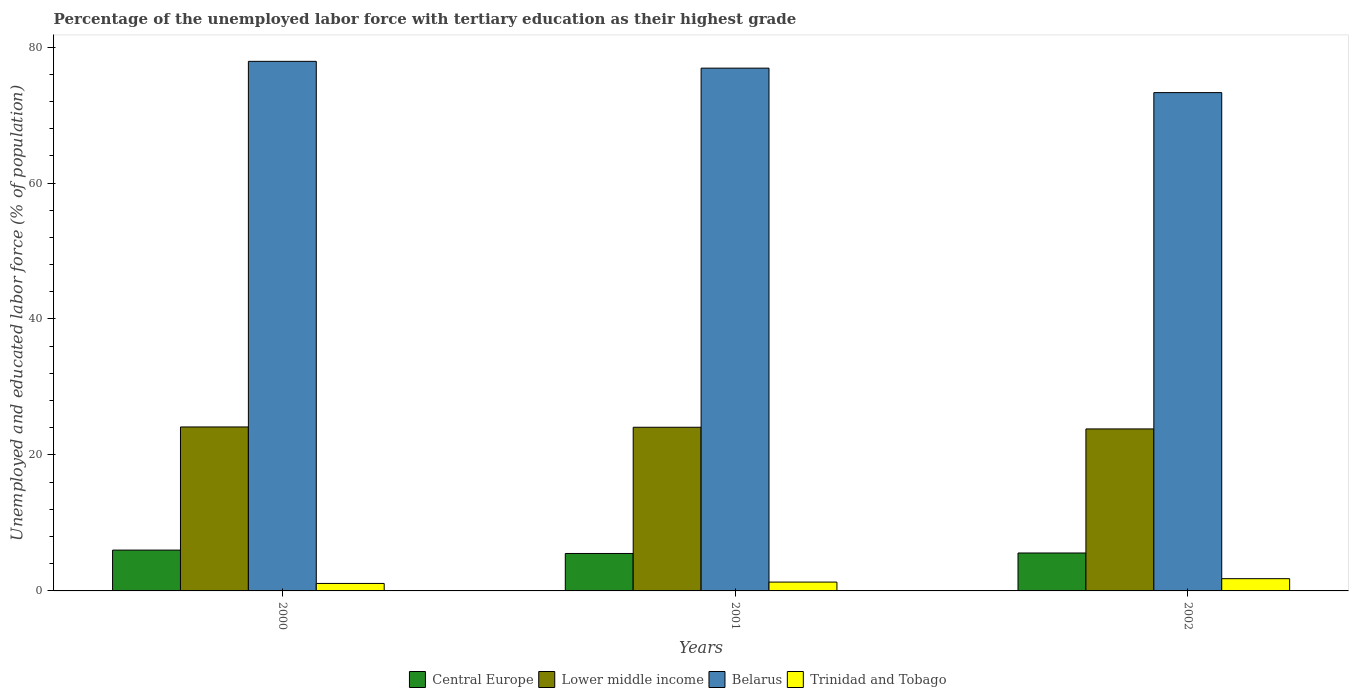How many bars are there on the 1st tick from the left?
Keep it short and to the point. 4. What is the label of the 2nd group of bars from the left?
Make the answer very short. 2001. In how many cases, is the number of bars for a given year not equal to the number of legend labels?
Offer a terse response. 0. What is the percentage of the unemployed labor force with tertiary education in Belarus in 2000?
Provide a succinct answer. 77.9. Across all years, what is the maximum percentage of the unemployed labor force with tertiary education in Lower middle income?
Provide a short and direct response. 24.12. Across all years, what is the minimum percentage of the unemployed labor force with tertiary education in Lower middle income?
Your answer should be compact. 23.83. In which year was the percentage of the unemployed labor force with tertiary education in Trinidad and Tobago minimum?
Keep it short and to the point. 2000. What is the total percentage of the unemployed labor force with tertiary education in Central Europe in the graph?
Your response must be concise. 17.09. What is the difference between the percentage of the unemployed labor force with tertiary education in Lower middle income in 2001 and that in 2002?
Make the answer very short. 0.25. What is the difference between the percentage of the unemployed labor force with tertiary education in Trinidad and Tobago in 2000 and the percentage of the unemployed labor force with tertiary education in Belarus in 2001?
Your answer should be compact. -75.8. What is the average percentage of the unemployed labor force with tertiary education in Central Europe per year?
Provide a short and direct response. 5.7. In the year 2001, what is the difference between the percentage of the unemployed labor force with tertiary education in Central Europe and percentage of the unemployed labor force with tertiary education in Trinidad and Tobago?
Keep it short and to the point. 4.21. What is the ratio of the percentage of the unemployed labor force with tertiary education in Trinidad and Tobago in 2000 to that in 2002?
Ensure brevity in your answer.  0.61. Is the difference between the percentage of the unemployed labor force with tertiary education in Central Europe in 2000 and 2002 greater than the difference between the percentage of the unemployed labor force with tertiary education in Trinidad and Tobago in 2000 and 2002?
Your response must be concise. Yes. What is the difference between the highest and the lowest percentage of the unemployed labor force with tertiary education in Central Europe?
Ensure brevity in your answer.  0.5. In how many years, is the percentage of the unemployed labor force with tertiary education in Central Europe greater than the average percentage of the unemployed labor force with tertiary education in Central Europe taken over all years?
Your response must be concise. 1. Is the sum of the percentage of the unemployed labor force with tertiary education in Central Europe in 2000 and 2002 greater than the maximum percentage of the unemployed labor force with tertiary education in Lower middle income across all years?
Offer a very short reply. No. Is it the case that in every year, the sum of the percentage of the unemployed labor force with tertiary education in Lower middle income and percentage of the unemployed labor force with tertiary education in Central Europe is greater than the sum of percentage of the unemployed labor force with tertiary education in Belarus and percentage of the unemployed labor force with tertiary education in Trinidad and Tobago?
Provide a short and direct response. Yes. What does the 1st bar from the left in 2001 represents?
Keep it short and to the point. Central Europe. What does the 3rd bar from the right in 2001 represents?
Make the answer very short. Lower middle income. Is it the case that in every year, the sum of the percentage of the unemployed labor force with tertiary education in Central Europe and percentage of the unemployed labor force with tertiary education in Lower middle income is greater than the percentage of the unemployed labor force with tertiary education in Trinidad and Tobago?
Offer a terse response. Yes. How many bars are there?
Make the answer very short. 12. What is the difference between two consecutive major ticks on the Y-axis?
Your response must be concise. 20. Are the values on the major ticks of Y-axis written in scientific E-notation?
Offer a very short reply. No. Does the graph contain any zero values?
Keep it short and to the point. No. Does the graph contain grids?
Offer a very short reply. No. How are the legend labels stacked?
Give a very brief answer. Horizontal. What is the title of the graph?
Provide a short and direct response. Percentage of the unemployed labor force with tertiary education as their highest grade. Does "Cameroon" appear as one of the legend labels in the graph?
Provide a short and direct response. No. What is the label or title of the Y-axis?
Your answer should be very brief. Unemployed and educated labor force (% of population). What is the Unemployed and educated labor force (% of population) of Central Europe in 2000?
Your answer should be compact. 6.01. What is the Unemployed and educated labor force (% of population) in Lower middle income in 2000?
Keep it short and to the point. 24.12. What is the Unemployed and educated labor force (% of population) of Belarus in 2000?
Make the answer very short. 77.9. What is the Unemployed and educated labor force (% of population) in Trinidad and Tobago in 2000?
Make the answer very short. 1.1. What is the Unemployed and educated labor force (% of population) in Central Europe in 2001?
Provide a succinct answer. 5.51. What is the Unemployed and educated labor force (% of population) of Lower middle income in 2001?
Your response must be concise. 24.08. What is the Unemployed and educated labor force (% of population) of Belarus in 2001?
Ensure brevity in your answer.  76.9. What is the Unemployed and educated labor force (% of population) of Trinidad and Tobago in 2001?
Your answer should be very brief. 1.3. What is the Unemployed and educated labor force (% of population) in Central Europe in 2002?
Offer a terse response. 5.58. What is the Unemployed and educated labor force (% of population) of Lower middle income in 2002?
Ensure brevity in your answer.  23.83. What is the Unemployed and educated labor force (% of population) in Belarus in 2002?
Offer a terse response. 73.3. What is the Unemployed and educated labor force (% of population) in Trinidad and Tobago in 2002?
Offer a very short reply. 1.8. Across all years, what is the maximum Unemployed and educated labor force (% of population) of Central Europe?
Your answer should be compact. 6.01. Across all years, what is the maximum Unemployed and educated labor force (% of population) of Lower middle income?
Your response must be concise. 24.12. Across all years, what is the maximum Unemployed and educated labor force (% of population) in Belarus?
Ensure brevity in your answer.  77.9. Across all years, what is the maximum Unemployed and educated labor force (% of population) in Trinidad and Tobago?
Offer a very short reply. 1.8. Across all years, what is the minimum Unemployed and educated labor force (% of population) in Central Europe?
Offer a very short reply. 5.51. Across all years, what is the minimum Unemployed and educated labor force (% of population) of Lower middle income?
Ensure brevity in your answer.  23.83. Across all years, what is the minimum Unemployed and educated labor force (% of population) in Belarus?
Your answer should be compact. 73.3. Across all years, what is the minimum Unemployed and educated labor force (% of population) of Trinidad and Tobago?
Provide a short and direct response. 1.1. What is the total Unemployed and educated labor force (% of population) in Central Europe in the graph?
Offer a terse response. 17.09. What is the total Unemployed and educated labor force (% of population) of Lower middle income in the graph?
Provide a short and direct response. 72.03. What is the total Unemployed and educated labor force (% of population) in Belarus in the graph?
Provide a short and direct response. 228.1. What is the total Unemployed and educated labor force (% of population) of Trinidad and Tobago in the graph?
Ensure brevity in your answer.  4.2. What is the difference between the Unemployed and educated labor force (% of population) in Central Europe in 2000 and that in 2001?
Keep it short and to the point. 0.5. What is the difference between the Unemployed and educated labor force (% of population) in Lower middle income in 2000 and that in 2001?
Your answer should be compact. 0.04. What is the difference between the Unemployed and educated labor force (% of population) in Trinidad and Tobago in 2000 and that in 2001?
Give a very brief answer. -0.2. What is the difference between the Unemployed and educated labor force (% of population) of Central Europe in 2000 and that in 2002?
Provide a short and direct response. 0.43. What is the difference between the Unemployed and educated labor force (% of population) of Lower middle income in 2000 and that in 2002?
Your response must be concise. 0.29. What is the difference between the Unemployed and educated labor force (% of population) in Belarus in 2000 and that in 2002?
Provide a short and direct response. 4.6. What is the difference between the Unemployed and educated labor force (% of population) of Trinidad and Tobago in 2000 and that in 2002?
Make the answer very short. -0.7. What is the difference between the Unemployed and educated labor force (% of population) in Central Europe in 2001 and that in 2002?
Provide a short and direct response. -0.07. What is the difference between the Unemployed and educated labor force (% of population) in Lower middle income in 2001 and that in 2002?
Ensure brevity in your answer.  0.25. What is the difference between the Unemployed and educated labor force (% of population) of Belarus in 2001 and that in 2002?
Ensure brevity in your answer.  3.6. What is the difference between the Unemployed and educated labor force (% of population) of Central Europe in 2000 and the Unemployed and educated labor force (% of population) of Lower middle income in 2001?
Your response must be concise. -18.07. What is the difference between the Unemployed and educated labor force (% of population) of Central Europe in 2000 and the Unemployed and educated labor force (% of population) of Belarus in 2001?
Keep it short and to the point. -70.89. What is the difference between the Unemployed and educated labor force (% of population) in Central Europe in 2000 and the Unemployed and educated labor force (% of population) in Trinidad and Tobago in 2001?
Provide a short and direct response. 4.71. What is the difference between the Unemployed and educated labor force (% of population) in Lower middle income in 2000 and the Unemployed and educated labor force (% of population) in Belarus in 2001?
Your answer should be very brief. -52.78. What is the difference between the Unemployed and educated labor force (% of population) of Lower middle income in 2000 and the Unemployed and educated labor force (% of population) of Trinidad and Tobago in 2001?
Offer a terse response. 22.82. What is the difference between the Unemployed and educated labor force (% of population) in Belarus in 2000 and the Unemployed and educated labor force (% of population) in Trinidad and Tobago in 2001?
Your answer should be compact. 76.6. What is the difference between the Unemployed and educated labor force (% of population) in Central Europe in 2000 and the Unemployed and educated labor force (% of population) in Lower middle income in 2002?
Provide a succinct answer. -17.83. What is the difference between the Unemployed and educated labor force (% of population) of Central Europe in 2000 and the Unemployed and educated labor force (% of population) of Belarus in 2002?
Your response must be concise. -67.3. What is the difference between the Unemployed and educated labor force (% of population) of Central Europe in 2000 and the Unemployed and educated labor force (% of population) of Trinidad and Tobago in 2002?
Ensure brevity in your answer.  4.21. What is the difference between the Unemployed and educated labor force (% of population) of Lower middle income in 2000 and the Unemployed and educated labor force (% of population) of Belarus in 2002?
Give a very brief answer. -49.18. What is the difference between the Unemployed and educated labor force (% of population) of Lower middle income in 2000 and the Unemployed and educated labor force (% of population) of Trinidad and Tobago in 2002?
Your answer should be very brief. 22.32. What is the difference between the Unemployed and educated labor force (% of population) in Belarus in 2000 and the Unemployed and educated labor force (% of population) in Trinidad and Tobago in 2002?
Your response must be concise. 76.1. What is the difference between the Unemployed and educated labor force (% of population) in Central Europe in 2001 and the Unemployed and educated labor force (% of population) in Lower middle income in 2002?
Offer a terse response. -18.32. What is the difference between the Unemployed and educated labor force (% of population) in Central Europe in 2001 and the Unemployed and educated labor force (% of population) in Belarus in 2002?
Offer a very short reply. -67.79. What is the difference between the Unemployed and educated labor force (% of population) in Central Europe in 2001 and the Unemployed and educated labor force (% of population) in Trinidad and Tobago in 2002?
Your answer should be compact. 3.71. What is the difference between the Unemployed and educated labor force (% of population) of Lower middle income in 2001 and the Unemployed and educated labor force (% of population) of Belarus in 2002?
Make the answer very short. -49.22. What is the difference between the Unemployed and educated labor force (% of population) in Lower middle income in 2001 and the Unemployed and educated labor force (% of population) in Trinidad and Tobago in 2002?
Provide a short and direct response. 22.28. What is the difference between the Unemployed and educated labor force (% of population) in Belarus in 2001 and the Unemployed and educated labor force (% of population) in Trinidad and Tobago in 2002?
Ensure brevity in your answer.  75.1. What is the average Unemployed and educated labor force (% of population) in Central Europe per year?
Offer a very short reply. 5.7. What is the average Unemployed and educated labor force (% of population) of Lower middle income per year?
Make the answer very short. 24.01. What is the average Unemployed and educated labor force (% of population) of Belarus per year?
Provide a short and direct response. 76.03. What is the average Unemployed and educated labor force (% of population) in Trinidad and Tobago per year?
Offer a very short reply. 1.4. In the year 2000, what is the difference between the Unemployed and educated labor force (% of population) in Central Europe and Unemployed and educated labor force (% of population) in Lower middle income?
Your answer should be compact. -18.11. In the year 2000, what is the difference between the Unemployed and educated labor force (% of population) in Central Europe and Unemployed and educated labor force (% of population) in Belarus?
Keep it short and to the point. -71.89. In the year 2000, what is the difference between the Unemployed and educated labor force (% of population) in Central Europe and Unemployed and educated labor force (% of population) in Trinidad and Tobago?
Keep it short and to the point. 4.91. In the year 2000, what is the difference between the Unemployed and educated labor force (% of population) of Lower middle income and Unemployed and educated labor force (% of population) of Belarus?
Provide a short and direct response. -53.78. In the year 2000, what is the difference between the Unemployed and educated labor force (% of population) in Lower middle income and Unemployed and educated labor force (% of population) in Trinidad and Tobago?
Give a very brief answer. 23.02. In the year 2000, what is the difference between the Unemployed and educated labor force (% of population) of Belarus and Unemployed and educated labor force (% of population) of Trinidad and Tobago?
Provide a short and direct response. 76.8. In the year 2001, what is the difference between the Unemployed and educated labor force (% of population) of Central Europe and Unemployed and educated labor force (% of population) of Lower middle income?
Your answer should be very brief. -18.57. In the year 2001, what is the difference between the Unemployed and educated labor force (% of population) of Central Europe and Unemployed and educated labor force (% of population) of Belarus?
Provide a succinct answer. -71.39. In the year 2001, what is the difference between the Unemployed and educated labor force (% of population) of Central Europe and Unemployed and educated labor force (% of population) of Trinidad and Tobago?
Your answer should be compact. 4.21. In the year 2001, what is the difference between the Unemployed and educated labor force (% of population) in Lower middle income and Unemployed and educated labor force (% of population) in Belarus?
Provide a succinct answer. -52.82. In the year 2001, what is the difference between the Unemployed and educated labor force (% of population) in Lower middle income and Unemployed and educated labor force (% of population) in Trinidad and Tobago?
Provide a succinct answer. 22.78. In the year 2001, what is the difference between the Unemployed and educated labor force (% of population) of Belarus and Unemployed and educated labor force (% of population) of Trinidad and Tobago?
Provide a short and direct response. 75.6. In the year 2002, what is the difference between the Unemployed and educated labor force (% of population) in Central Europe and Unemployed and educated labor force (% of population) in Lower middle income?
Your answer should be very brief. -18.25. In the year 2002, what is the difference between the Unemployed and educated labor force (% of population) of Central Europe and Unemployed and educated labor force (% of population) of Belarus?
Ensure brevity in your answer.  -67.72. In the year 2002, what is the difference between the Unemployed and educated labor force (% of population) of Central Europe and Unemployed and educated labor force (% of population) of Trinidad and Tobago?
Give a very brief answer. 3.78. In the year 2002, what is the difference between the Unemployed and educated labor force (% of population) in Lower middle income and Unemployed and educated labor force (% of population) in Belarus?
Ensure brevity in your answer.  -49.47. In the year 2002, what is the difference between the Unemployed and educated labor force (% of population) of Lower middle income and Unemployed and educated labor force (% of population) of Trinidad and Tobago?
Make the answer very short. 22.03. In the year 2002, what is the difference between the Unemployed and educated labor force (% of population) of Belarus and Unemployed and educated labor force (% of population) of Trinidad and Tobago?
Keep it short and to the point. 71.5. What is the ratio of the Unemployed and educated labor force (% of population) of Central Europe in 2000 to that in 2001?
Give a very brief answer. 1.09. What is the ratio of the Unemployed and educated labor force (% of population) in Trinidad and Tobago in 2000 to that in 2001?
Offer a terse response. 0.85. What is the ratio of the Unemployed and educated labor force (% of population) of Central Europe in 2000 to that in 2002?
Your response must be concise. 1.08. What is the ratio of the Unemployed and educated labor force (% of population) of Lower middle income in 2000 to that in 2002?
Ensure brevity in your answer.  1.01. What is the ratio of the Unemployed and educated labor force (% of population) in Belarus in 2000 to that in 2002?
Your answer should be very brief. 1.06. What is the ratio of the Unemployed and educated labor force (% of population) of Trinidad and Tobago in 2000 to that in 2002?
Provide a succinct answer. 0.61. What is the ratio of the Unemployed and educated labor force (% of population) in Lower middle income in 2001 to that in 2002?
Provide a succinct answer. 1.01. What is the ratio of the Unemployed and educated labor force (% of population) of Belarus in 2001 to that in 2002?
Provide a succinct answer. 1.05. What is the ratio of the Unemployed and educated labor force (% of population) in Trinidad and Tobago in 2001 to that in 2002?
Keep it short and to the point. 0.72. What is the difference between the highest and the second highest Unemployed and educated labor force (% of population) of Central Europe?
Offer a very short reply. 0.43. What is the difference between the highest and the second highest Unemployed and educated labor force (% of population) in Lower middle income?
Offer a terse response. 0.04. What is the difference between the highest and the lowest Unemployed and educated labor force (% of population) in Central Europe?
Keep it short and to the point. 0.5. What is the difference between the highest and the lowest Unemployed and educated labor force (% of population) of Lower middle income?
Make the answer very short. 0.29. What is the difference between the highest and the lowest Unemployed and educated labor force (% of population) in Trinidad and Tobago?
Make the answer very short. 0.7. 